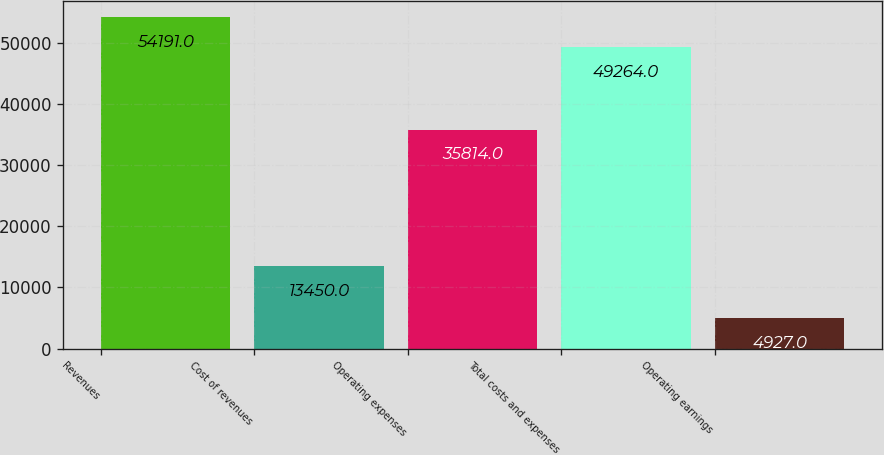<chart> <loc_0><loc_0><loc_500><loc_500><bar_chart><fcel>Revenues<fcel>Cost of revenues<fcel>Operating expenses<fcel>Total costs and expenses<fcel>Operating earnings<nl><fcel>54191<fcel>13450<fcel>35814<fcel>49264<fcel>4927<nl></chart> 